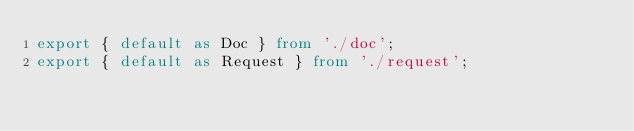Convert code to text. <code><loc_0><loc_0><loc_500><loc_500><_TypeScript_>export { default as Doc } from './doc';
export { default as Request } from './request';</code> 